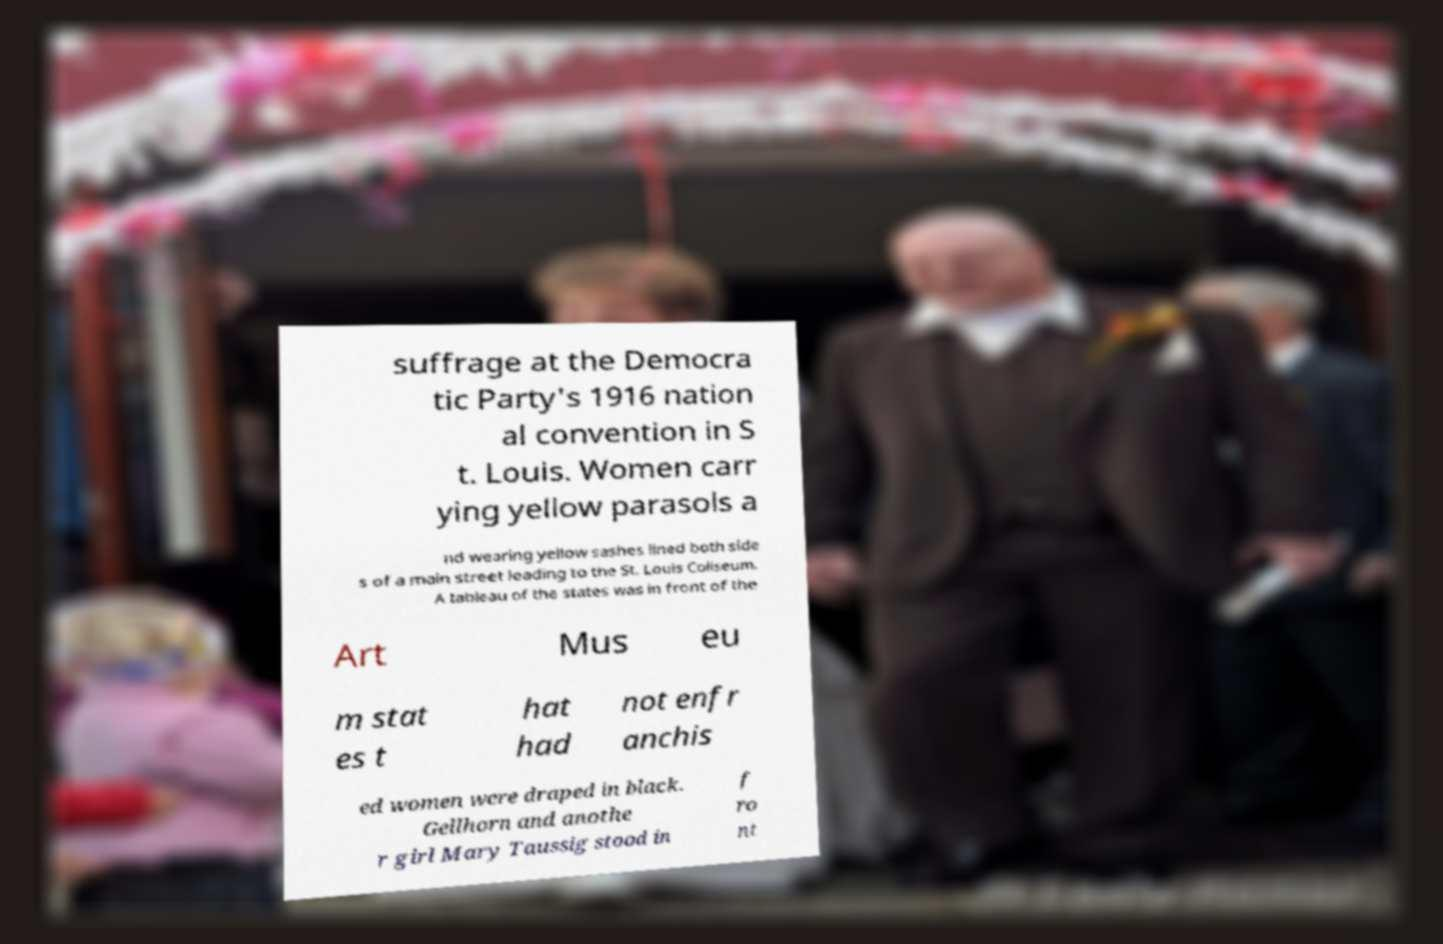Can you read and provide the text displayed in the image?This photo seems to have some interesting text. Can you extract and type it out for me? suffrage at the Democra tic Party's 1916 nation al convention in S t. Louis. Women carr ying yellow parasols a nd wearing yellow sashes lined both side s of a main street leading to the St. Louis Coliseum. A tableau of the states was in front of the Art Mus eu m stat es t hat had not enfr anchis ed women were draped in black. Gellhorn and anothe r girl Mary Taussig stood in f ro nt 